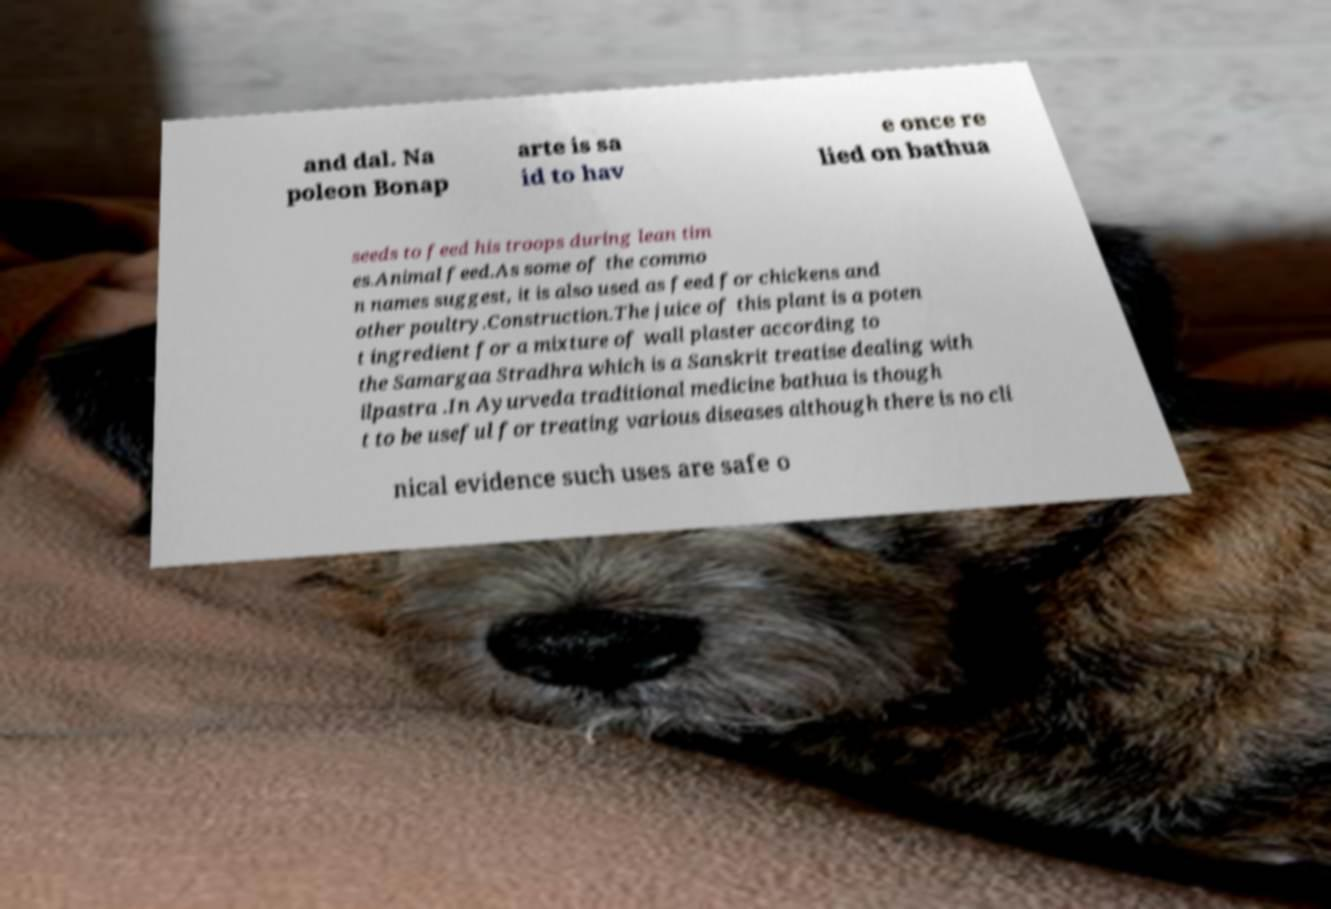I need the written content from this picture converted into text. Can you do that? and dal. Na poleon Bonap arte is sa id to hav e once re lied on bathua seeds to feed his troops during lean tim es.Animal feed.As some of the commo n names suggest, it is also used as feed for chickens and other poultry.Construction.The juice of this plant is a poten t ingredient for a mixture of wall plaster according to the Samargaa Stradhra which is a Sanskrit treatise dealing with ilpastra .In Ayurveda traditional medicine bathua is though t to be useful for treating various diseases although there is no cli nical evidence such uses are safe o 